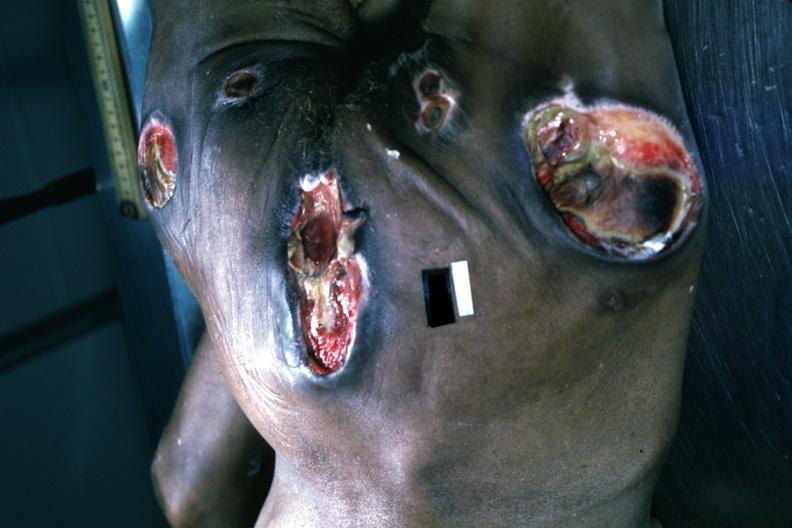s subependymal giant cell astrocytoma present?
Answer the question using a single word or phrase. No 